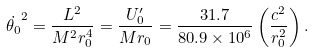<formula> <loc_0><loc_0><loc_500><loc_500>\dot { \theta _ { 0 } } ^ { 2 } = \frac { L ^ { 2 } } { M ^ { 2 } r _ { 0 } ^ { 4 } } = \frac { U _ { 0 } ^ { \prime } } { M r _ { 0 } } = \frac { 3 1 . 7 } { 8 0 . 9 \times 1 0 ^ { 6 } } \left ( \frac { c ^ { 2 } } { r _ { 0 } ^ { 2 } } \right ) .</formula> 